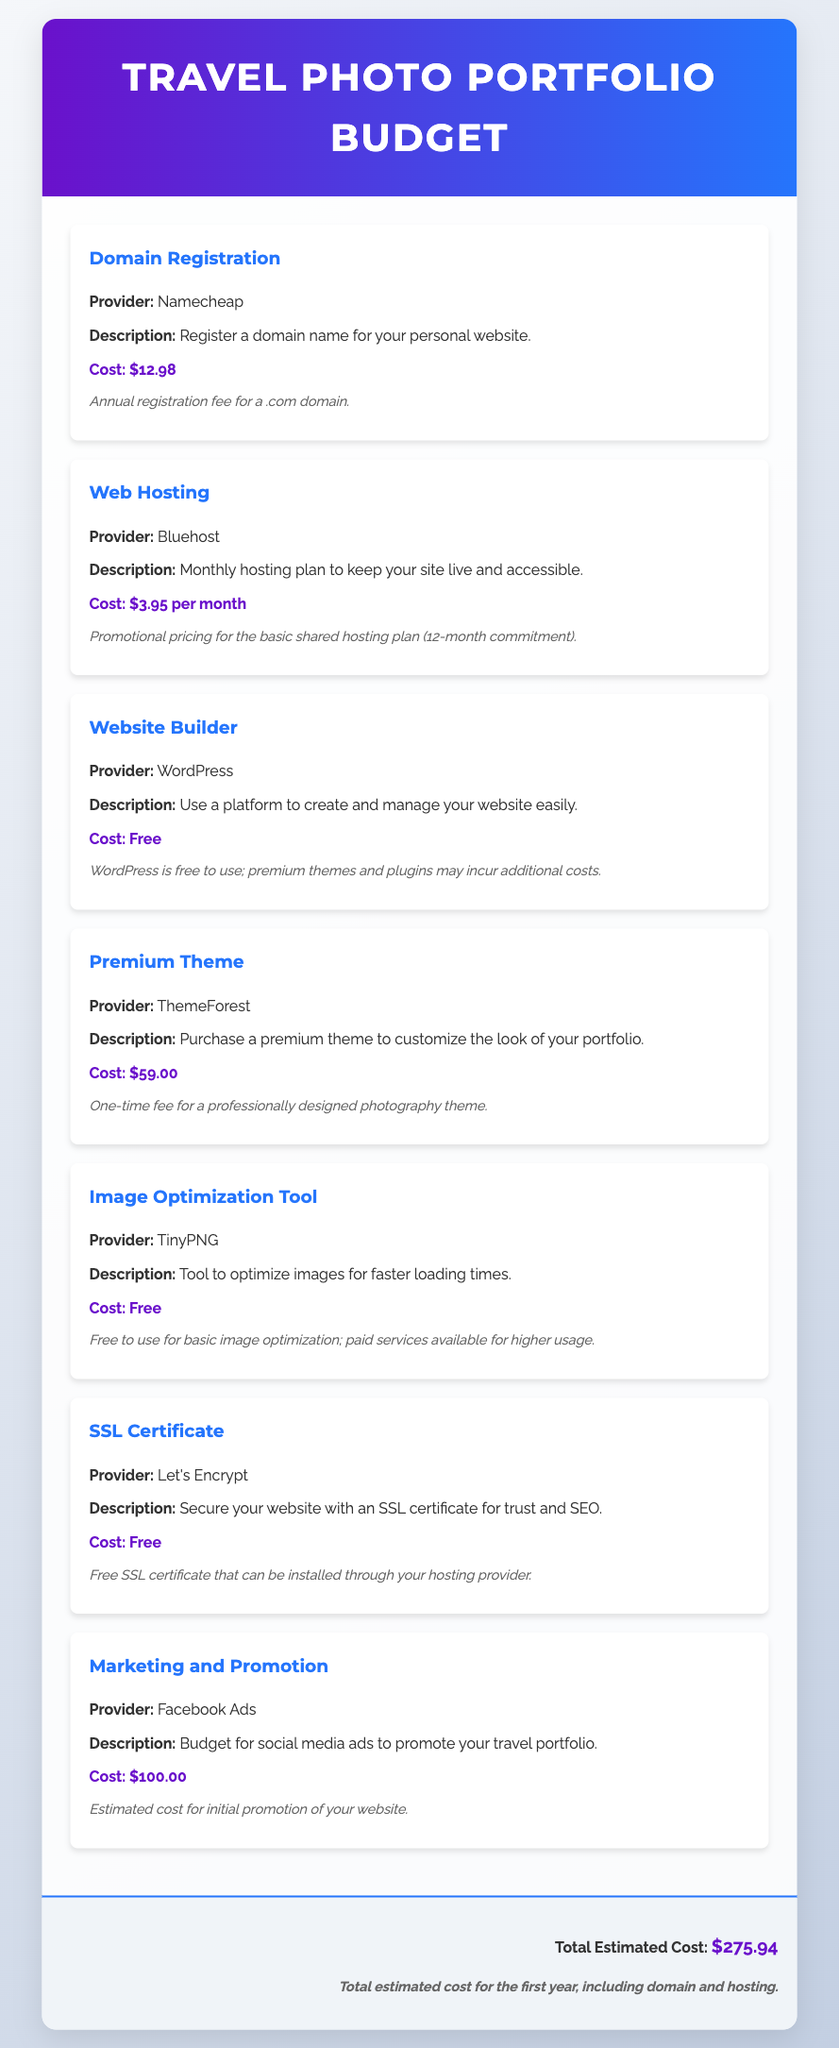What is the cost of domain registration? The cost of domain registration is stated clearly in the document under "Domain Registration" as $12.98.
Answer: $12.98 What is the monthly cost of web hosting? The document specifies the monthly cost of web hosting under "Web Hosting" as $3.95 per month.
Answer: $3.95 per month What is the total estimated cost for the first year? The total estimated cost mentioned at the end of the document sums up all costs, which is $275.94.
Answer: $275.94 What provider is used for the premium theme? The document lists ThemeForest as the provider for the premium theme under "Premium Theme."
Answer: ThemeForest How much is budgeted for marketing and promotion? The allocation for marketing and promotion is detailed under "Marketing and Promotion" as $100.00.
Answer: $100.00 What is the cost of the premium theme? The document states the cost of the premium theme under "Premium Theme" as a one-time fee of $59.00.
Answer: $59.00 Which tool is free for image optimization? The document identifies TinyPNG as the tool for image optimization that is free to use.
Answer: TinyPNG What is included in the SSL certificate section? The document mentions that Let's Encrypt provides a free SSL certificate for securing the website.
Answer: Let's Encrypt What is the description of the website builder? The document describes the website builder as a platform to create and manage your website easily under "Website Builder."
Answer: Use a platform to create and manage your website easily 